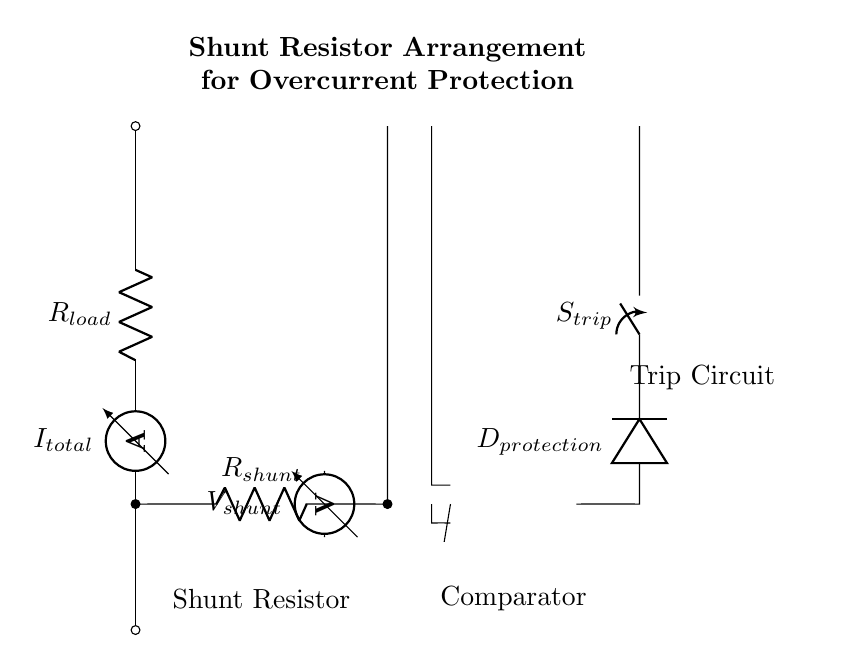What is the total current in the circuit? The total current in the circuit is represented by \(I_{total}\), which is indicated by the ammeter at the top of the circuit.
Answer: I total What component provides overcurrent protection? The diode labeled \(D_{protection}\) is responsible for providing overcurrent protection. It allows current to flow in one direction and blocks reverse current, thus protecting the circuit.
Answer: D protection What does the shunt resistor measure? The shunt resistor \(R_{shunt}\) measures the current flowing through it, which can be related to the voltage drop across it, indicated by the voltmeter \(V_{shunt}\).
Answer: Current If the voltage across the shunt is high, what happens next? If the voltage across \(R_{shunt}\) is high, it triggers the comparator (operational amplifier). This results in the trip circuit \(S_{trip}\) closing, which disconnects the load and prevents damage due to overcurrent.
Answer: Trip What is the purpose of \(R_{load}\)? The purpose of \(R_{load}\) is to represent the load in the circuit that is being powered and monitored for current flow.
Answer: Load What happens to the trip circuit during a normal operation? During normal operation, the trip circuit remains open, allowing current to flow through \(R_{load}\). The protection mechanism is inactive unless an overcurrent condition occurs.
Answer: Open What is measured across the shunt resistor? The voltmeter measures the voltage drop across the shunt resistor, which is proportional to the current flowing through it as per Ohm's Law.
Answer: Voltage drop 